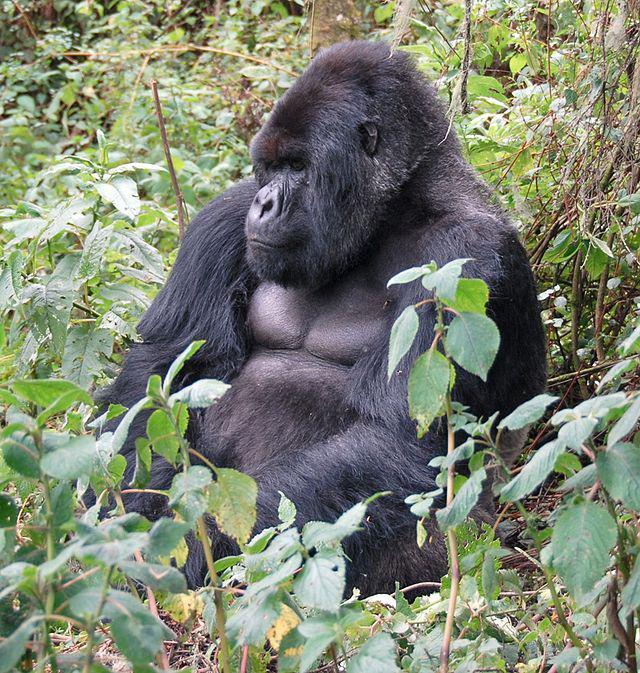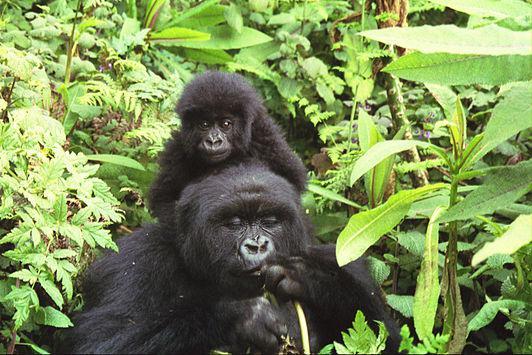The first image is the image on the left, the second image is the image on the right. Given the left and right images, does the statement "All of the images only contain one gorilla." hold true? Answer yes or no. No. The first image is the image on the left, the second image is the image on the right. Considering the images on both sides, is "There are two gorillas total." valid? Answer yes or no. No. 